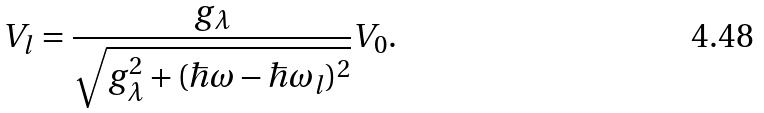Convert formula to latex. <formula><loc_0><loc_0><loc_500><loc_500>V _ { l } = \frac { g _ { \lambda } } { \sqrt { g _ { \lambda } ^ { 2 } + ( \hbar { \omega } - \hbar { \omega } _ { l } ) ^ { 2 } } } V _ { 0 } .</formula> 